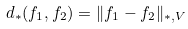Convert formula to latex. <formula><loc_0><loc_0><loc_500><loc_500>d _ { * } ( f _ { 1 } , f _ { 2 } ) = \| f _ { 1 } - f _ { 2 } \| _ { * , V }</formula> 